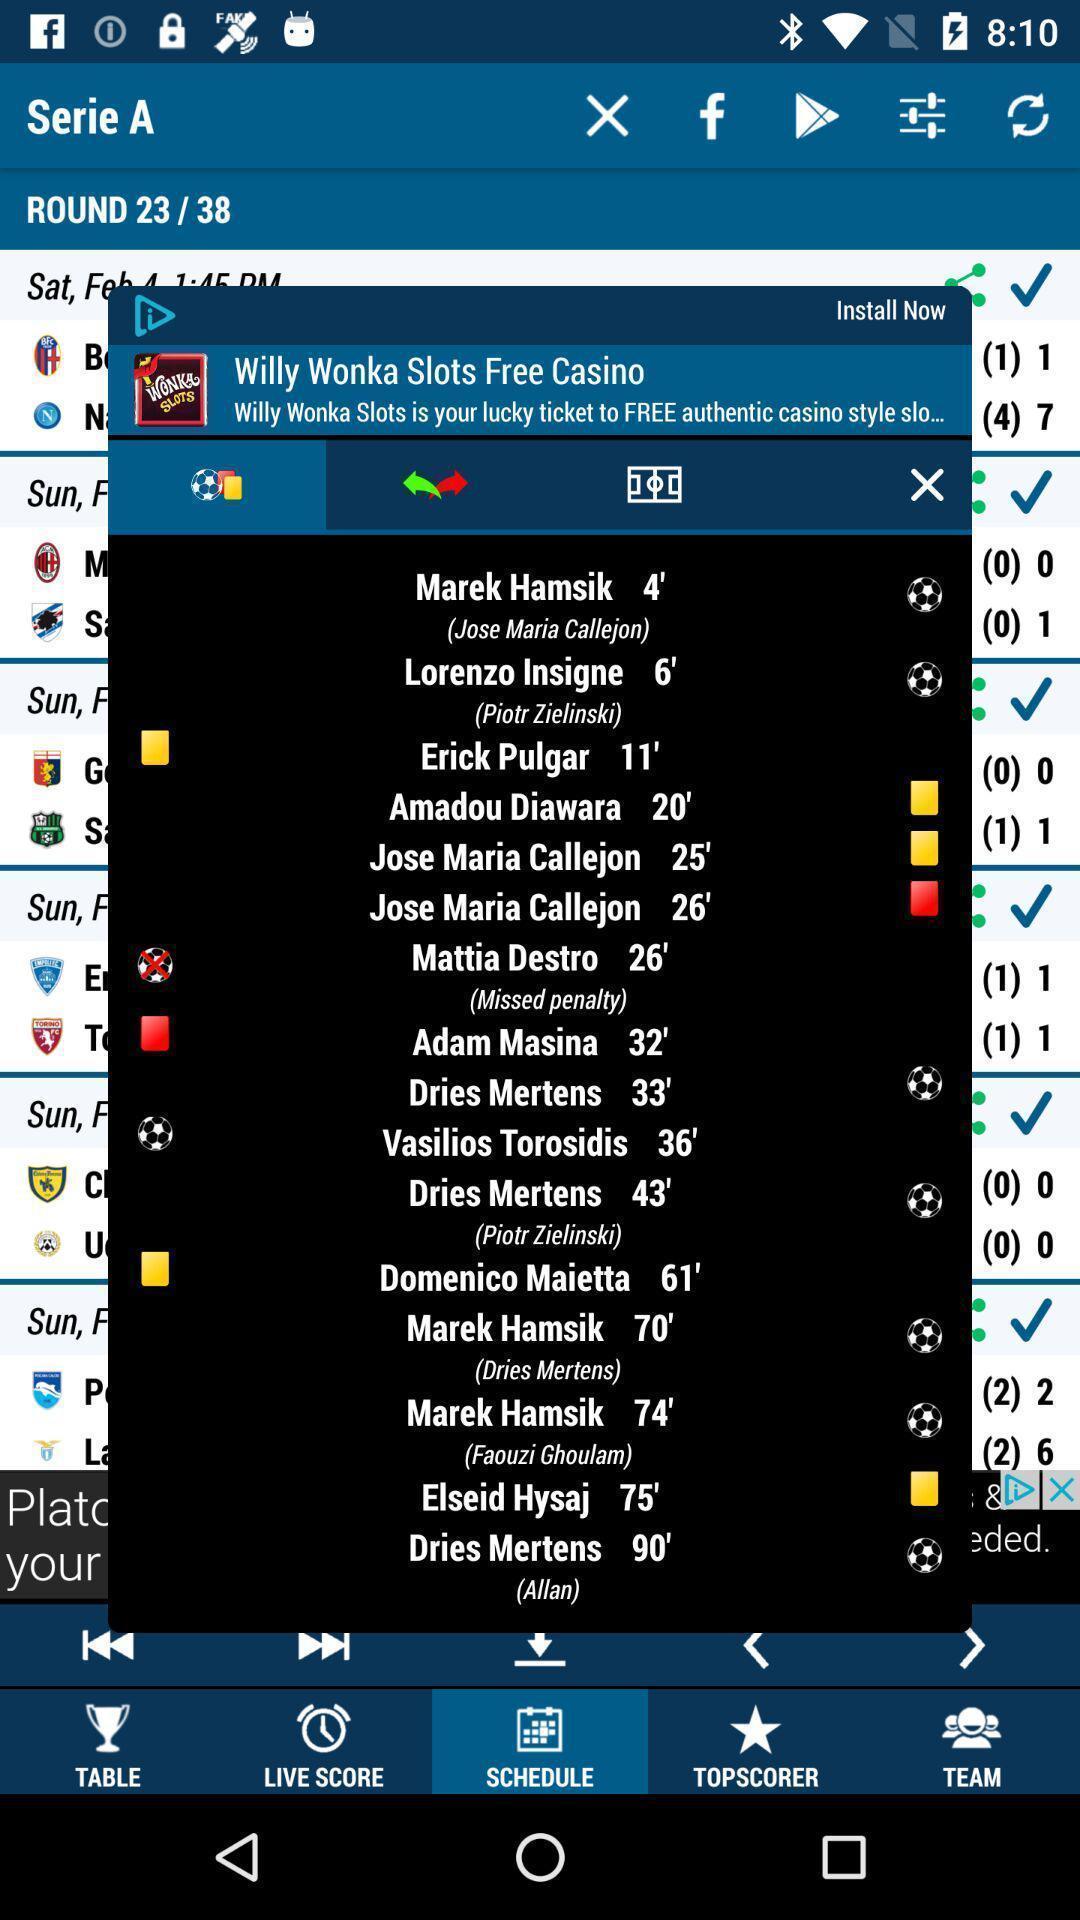Explain the elements present in this screenshot. Pop-up showing football game schedule in football game app. 